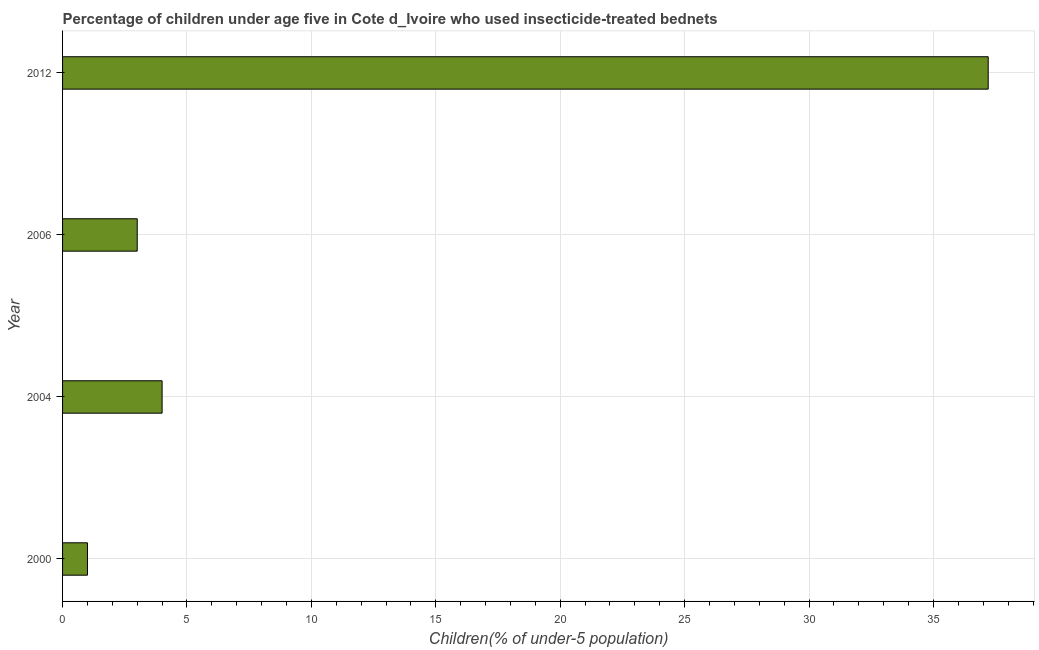Does the graph contain any zero values?
Make the answer very short. No. Does the graph contain grids?
Give a very brief answer. Yes. What is the title of the graph?
Offer a very short reply. Percentage of children under age five in Cote d_Ivoire who used insecticide-treated bednets. What is the label or title of the X-axis?
Provide a short and direct response. Children(% of under-5 population). What is the label or title of the Y-axis?
Ensure brevity in your answer.  Year. What is the percentage of children who use of insecticide-treated bed nets in 2012?
Ensure brevity in your answer.  37.2. Across all years, what is the maximum percentage of children who use of insecticide-treated bed nets?
Your response must be concise. 37.2. In which year was the percentage of children who use of insecticide-treated bed nets maximum?
Offer a terse response. 2012. In which year was the percentage of children who use of insecticide-treated bed nets minimum?
Offer a very short reply. 2000. What is the sum of the percentage of children who use of insecticide-treated bed nets?
Offer a terse response. 45.2. What is the difference between the percentage of children who use of insecticide-treated bed nets in 2000 and 2004?
Give a very brief answer. -3. What is the median percentage of children who use of insecticide-treated bed nets?
Your response must be concise. 3.5. Do a majority of the years between 2000 and 2004 (inclusive) have percentage of children who use of insecticide-treated bed nets greater than 16 %?
Keep it short and to the point. No. What is the ratio of the percentage of children who use of insecticide-treated bed nets in 2004 to that in 2012?
Provide a succinct answer. 0.11. Is the percentage of children who use of insecticide-treated bed nets in 2004 less than that in 2012?
Keep it short and to the point. Yes. Is the difference between the percentage of children who use of insecticide-treated bed nets in 2006 and 2012 greater than the difference between any two years?
Give a very brief answer. No. What is the difference between the highest and the second highest percentage of children who use of insecticide-treated bed nets?
Keep it short and to the point. 33.2. Is the sum of the percentage of children who use of insecticide-treated bed nets in 2004 and 2006 greater than the maximum percentage of children who use of insecticide-treated bed nets across all years?
Your answer should be compact. No. What is the difference between the highest and the lowest percentage of children who use of insecticide-treated bed nets?
Provide a short and direct response. 36.2. How many bars are there?
Ensure brevity in your answer.  4. What is the difference between two consecutive major ticks on the X-axis?
Give a very brief answer. 5. Are the values on the major ticks of X-axis written in scientific E-notation?
Your answer should be compact. No. What is the Children(% of under-5 population) in 2012?
Give a very brief answer. 37.2. What is the difference between the Children(% of under-5 population) in 2000 and 2004?
Your answer should be compact. -3. What is the difference between the Children(% of under-5 population) in 2000 and 2006?
Offer a very short reply. -2. What is the difference between the Children(% of under-5 population) in 2000 and 2012?
Offer a very short reply. -36.2. What is the difference between the Children(% of under-5 population) in 2004 and 2012?
Give a very brief answer. -33.2. What is the difference between the Children(% of under-5 population) in 2006 and 2012?
Offer a terse response. -34.2. What is the ratio of the Children(% of under-5 population) in 2000 to that in 2006?
Ensure brevity in your answer.  0.33. What is the ratio of the Children(% of under-5 population) in 2000 to that in 2012?
Offer a very short reply. 0.03. What is the ratio of the Children(% of under-5 population) in 2004 to that in 2006?
Your response must be concise. 1.33. What is the ratio of the Children(% of under-5 population) in 2004 to that in 2012?
Make the answer very short. 0.11. What is the ratio of the Children(% of under-5 population) in 2006 to that in 2012?
Ensure brevity in your answer.  0.08. 